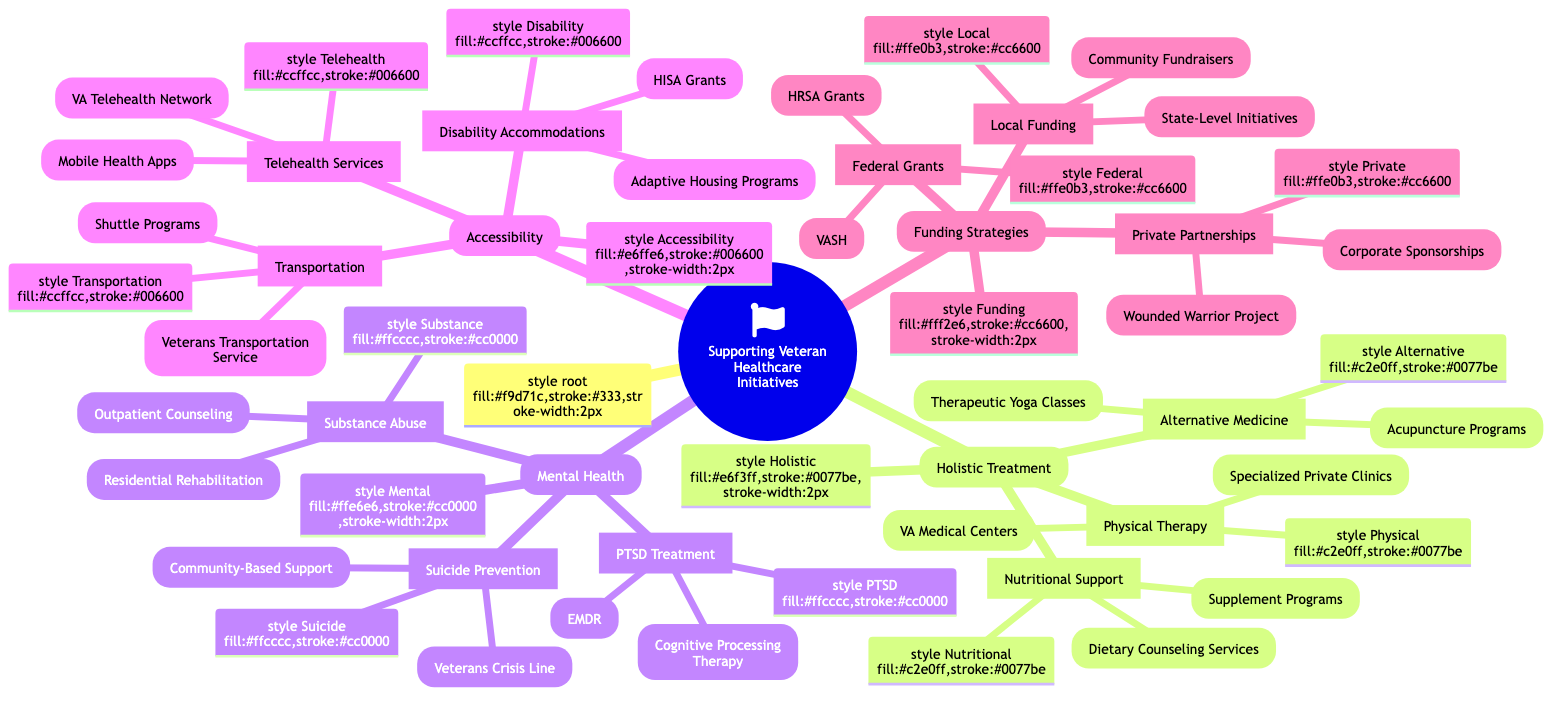What are the three main categories of supporting veteran healthcare initiatives? The diagram clearly lists three main categories: Holistic Treatment, Mental Health, and Accessibility, each of which addresses different areas of veteran healthcare.
Answer: Holistic Treatment, Mental Health, Accessibility How many subsections does the Mental Health category have? In the Mental Health category, there are three subsections: PTSD Treatment, Substance Abuse, and Suicide Prevention. Thus, the total count is three.
Answer: 3 What specific services are included under Telehealth Services? The Telehealth Services subsection lists two specific services: VA Telehealth Network and Mobile Health Apps, which provide virtual access to healthcare.
Answer: VA Telehealth Network, Mobile Health Apps Which funding strategy includes state-level initiatives? The Local Funding subsection contains State-Level Initiatives as one of its components, which refers to locally sourced funding to support veteran healthcare projects.
Answer: State-Level Initiatives What type of therapy is mentioned under PTSD Treatment? Under the PTSD Treatment subsection, Cognitive Processing Therapy is specified as one of the therapeutic approaches used for treating Post-Traumatic Stress Disorder among veterans.
Answer: Cognitive Processing Therapy How many alternative medicine programs are listed? The Alternative Medicine subsection includes two programs: Acupuncture Programs and Therapeutic Yoga Classes. Therefore, the total is two.
Answer: 2 Which category addresses accommodations for disabilities? The Accessibility category pertains specifically to disability accommodations, including provisions for veterans with physical limitations to access necessary healthcare services.
Answer: Accessibility What type of support does the Veterans Crisis Line provide? The Veterans Crisis Line offers suicide prevention support, specifically aiding veterans in crisis situations by providing immediate assistance.
Answer: Suicide prevention support How many private partnership initiatives are mentioned? The Funding Strategies category lists two private partnership initiatives: Wounded Warrior Project Collaborations and Corporate Sponsorships. Hence, there are two initiatives.
Answer: 2 